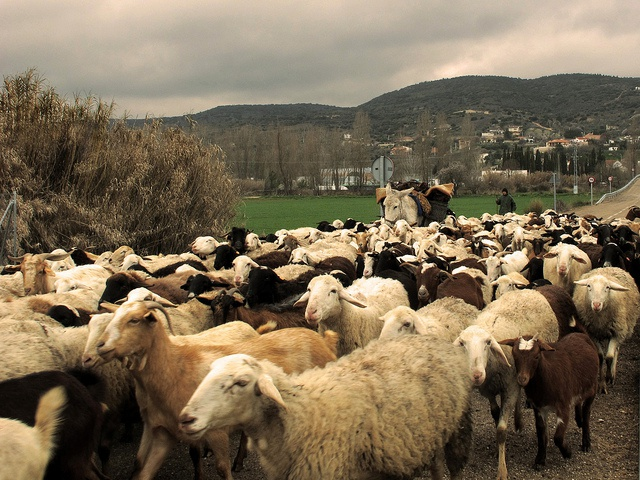Describe the objects in this image and their specific colors. I can see sheep in tan, black, and olive tones, sheep in tan, gray, olive, and black tones, sheep in tan, maroon, and black tones, sheep in tan and black tones, and sheep in tan, black, maroon, and gray tones in this image. 